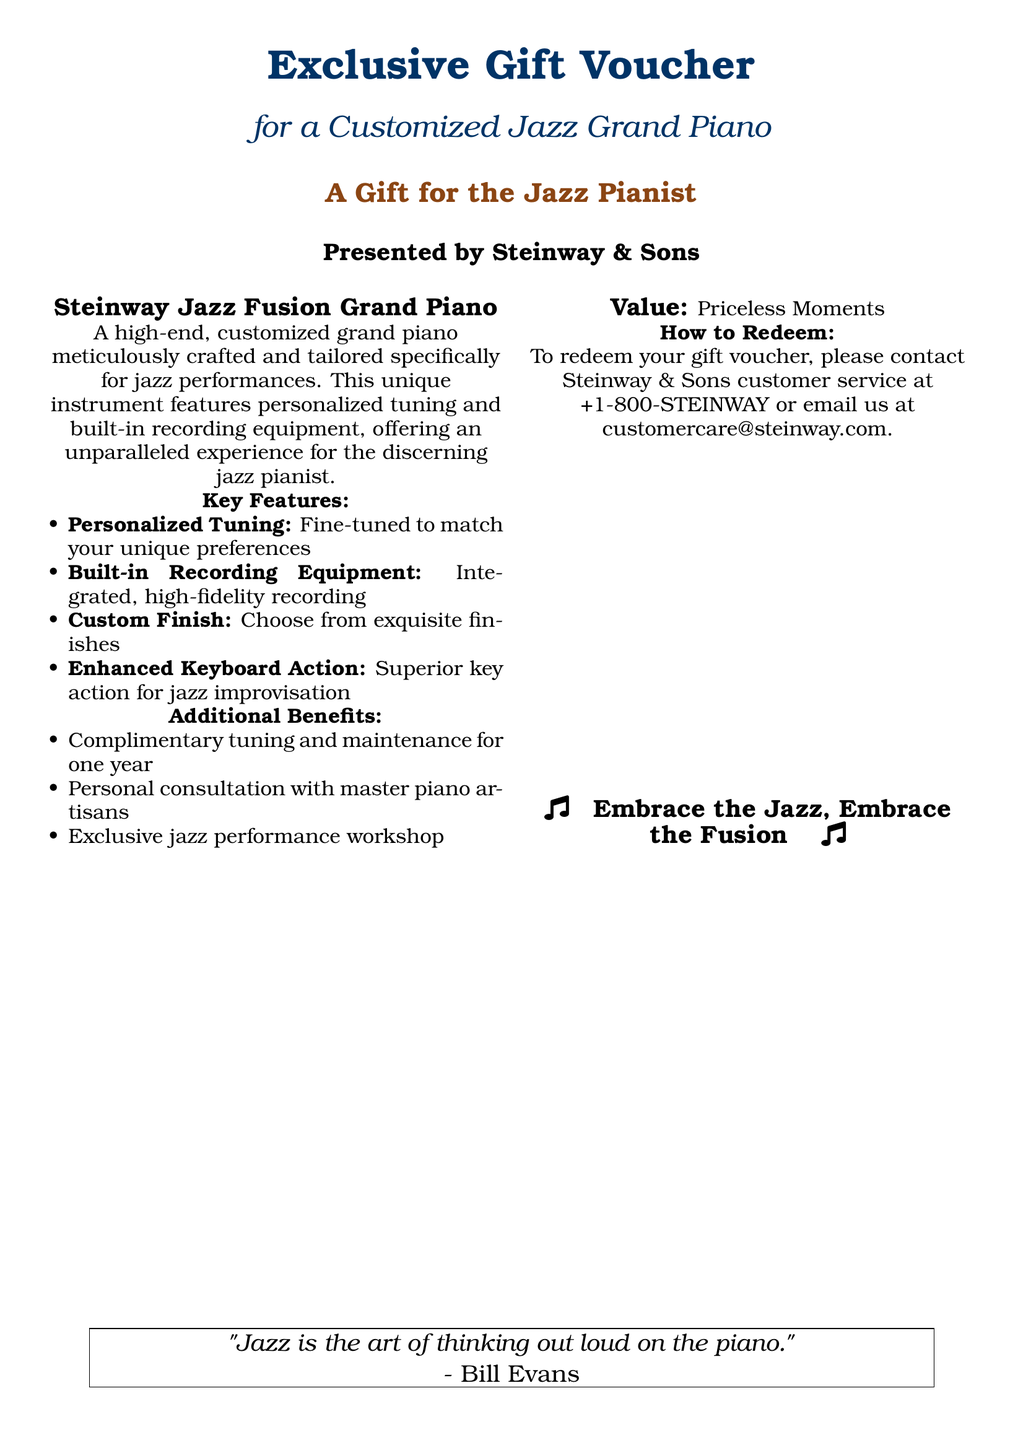What is the title of the gift voucher? The title of the gift voucher is prominently displayed at the top of the document.
Answer: Exclusive Gift Voucher Who is presenting the gift voucher? The document specifies who is presenting the voucher in a clear section.
Answer: Steinway & Sons What is the primary feature of the piano? The document highlights key features, with the first being the personalized tuning.
Answer: Personalized Tuning What kind of piano is featured in the voucher? The type of piano being offered is stated in the description.
Answer: Jazz Fusion Grand Piano What additional benefit is offered with the piano? The document lists several benefits; one of them mentions complimentary tuning.
Answer: Complimentary tuning and maintenance for one year How can one redeem the gift voucher? The redemption process is outlined in a specific section of the document.
Answer: Contact Steinway & Sons customer service What is included in the built-in feature of the piano? A key feature of the piano includes integrated functionality for a certain purpose.
Answer: Built-in Recording Equipment What does the quote in the box at the bottom say? The quote reflects a thought from a notable musician, providing insight into the art of jazz.
Answer: "Jazz is the art of thinking out loud on the piano." 